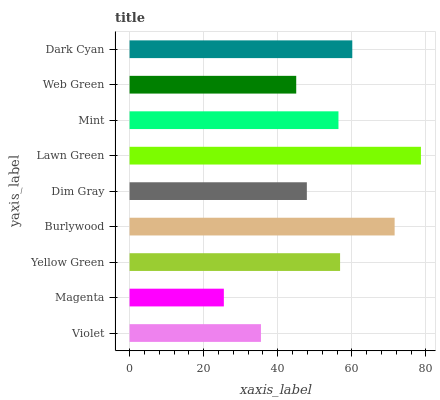Is Magenta the minimum?
Answer yes or no. Yes. Is Lawn Green the maximum?
Answer yes or no. Yes. Is Yellow Green the minimum?
Answer yes or no. No. Is Yellow Green the maximum?
Answer yes or no. No. Is Yellow Green greater than Magenta?
Answer yes or no. Yes. Is Magenta less than Yellow Green?
Answer yes or no. Yes. Is Magenta greater than Yellow Green?
Answer yes or no. No. Is Yellow Green less than Magenta?
Answer yes or no. No. Is Mint the high median?
Answer yes or no. Yes. Is Mint the low median?
Answer yes or no. Yes. Is Violet the high median?
Answer yes or no. No. Is Burlywood the low median?
Answer yes or no. No. 